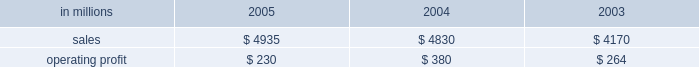Entering 2006 , earnings in the first quarter are ex- pected to improve compared with the 2005 fourth quar- ter due principally to higher average price realizations , reflecting announced price increases .
Product demand for the first quarter should be seasonally slow , but is ex- pected to strengthen as the year progresses , supported by continued economic growth in north america , asia and eastern europe .
Average prices should also improve in 2006 as price increases announced in late 2005 and early 2006 for uncoated freesheet paper and pulp con- tinue to be realized .
Operating rates are expected to improve as a result of industry-wide capacity reductions in 2005 .
Although energy and raw material costs remain high , there has been some decline in both natural gas and delivered wood costs , with further moderation ex- pected later in 2006 .
We will continue to focus on fur- ther improvements in our global manufacturing operations , implementation of supply chain enhance- ments and reductions in overhead costs during 2006 .
Industrial packaging demand for industrial packaging products is closely correlated with non-durable industrial goods production in the united states , as well as with demand for proc- essed foods , poultry , meat and agricultural products .
In addition to prices and volumes , major factors affecting the profitability of industrial packaging are raw material and energy costs , manufacturing efficiency and product industrial packaging 2019s net sales for 2005 increased 2% ( 2 % ) compared with 2004 , and were 18% ( 18 % ) higher than in 2003 , reflecting the inclusion of international paper distribution limited ( formerly international paper pacific millennium limited ) beginning in august 2005 .
Operating profits in 2005 were 39% ( 39 % ) lower than in 2004 and 13% ( 13 % ) lower than in 2003 .
Sales volume increases ( $ 24 million ) , improved price realizations ( $ 66 million ) , and strong mill operating performance ( $ 27 million ) were not enough to offset the effects of increased raw material costs ( $ 103 million ) , higher market related downtime costs ( $ 50 million ) , higher converting operating costs ( $ 22 million ) , and unfavorable mix and other costs ( $ 67 million ) .
Additionally , the may 2005 sale of our industrial papers business resulted in a $ 25 million lower earnings contribution from this business in 2005 .
The segment took 370000 tons of downtime in 2005 , including 230000 tons of lack-of-order downtime to balance internal supply with customer demand , com- pared to a total of 170000 tons in 2004 , which included 5000 tons of lack-of-order downtime .
Industrial packaging in millions 2005 2004 2003 .
Containerboard 2019s net sales totaled $ 895 million in 2005 , $ 951 million in 2004 and $ 815 million in 2003 .
Soft market conditions and declining customer demand at the end of the first quarter led to lower average sales prices during the second and third quarters .
Beginning in the fourth quarter , prices recovered as a result of in- creased customer demand and a rationalization of sup- ply .
Full year sales volumes trailed 2004 levels early in the year , reflecting the weak market conditions in the first half of 2005 .
However , volumes rebounded in the second half of the year , and finished the year ahead of 2004 levels .
Operating profits decreased 38% ( 38 % ) from 2004 , but were flat with 2003 .
The favorable impacts of in- creased sales volumes , higher average sales prices and improved mill operating performance were not enough to offset the impact of higher wood , energy and other raw material costs and increased lack-of-order down- time .
Implementation of the new supply chain operating model in our containerboard mills during 2005 resulted in increased operating efficiency and cost savings .
Specialty papers in 2005 included the kraft paper business for the full year and the industrial papers busi- ness for five months prior to its sale in may 2005 .
Net sales totaled $ 468 million in 2005 , $ 723 million in 2004 and $ 690 million in 2003 .
Operating profits in 2005 were down 23% ( 23 % ) compared with 2004 and 54% ( 54 % ) com- pared with 2003 , reflecting the lower contribution from industrial papers .
U.s .
Converting operations net sales for 2005 were $ 2.6 billion compared with $ 2.3 billion in 2004 and $ 1.9 billion in 2003 .
Sales volumes were up 10% ( 10 % ) in 2005 compared with 2004 , mainly due to the acquisition of box usa in july 2004 .
Average sales prices in 2005 began the year above 2004 levels , but softened in the second half of the year .
Operating profits in 2005 de- creased 46% ( 46 % ) and 4% ( 4 % ) from 2004 and 2003 levels , re- spectively , primarily due to increased linerboard , freight and energy costs .
European container sales for 2005 were $ 883 mil- lion compared with $ 865 million in 2004 and $ 801 mil- lion in 2003 .
Operating profits declined 19% ( 19 % ) and 13% ( 13 % ) compared with 2004 and 2003 , respectively .
The in- crease in sales in 2005 reflected a slight increase in de- mand over 2004 , but this was not sufficient to offset the negative earnings effect of increased operating costs , unfavorable foreign exchange rates and a reduction in average sales prices .
The moroccan box plant acquis- ition , which was completed in october 2005 , favorably impacted fourth-quarter results .
Industrial packaging 2019s sales in 2005 included $ 104 million from international paper distribution limited , our asian box and containerboard business , subsequent to the acquisition of an additional 50% ( 50 % ) interest in au- gust 2005. .
What was the average net sales from 2003 to 2005 in millions? 
Computations: ((((468 + 723) + 690) + 3) / 2)
Answer: 942.0. 